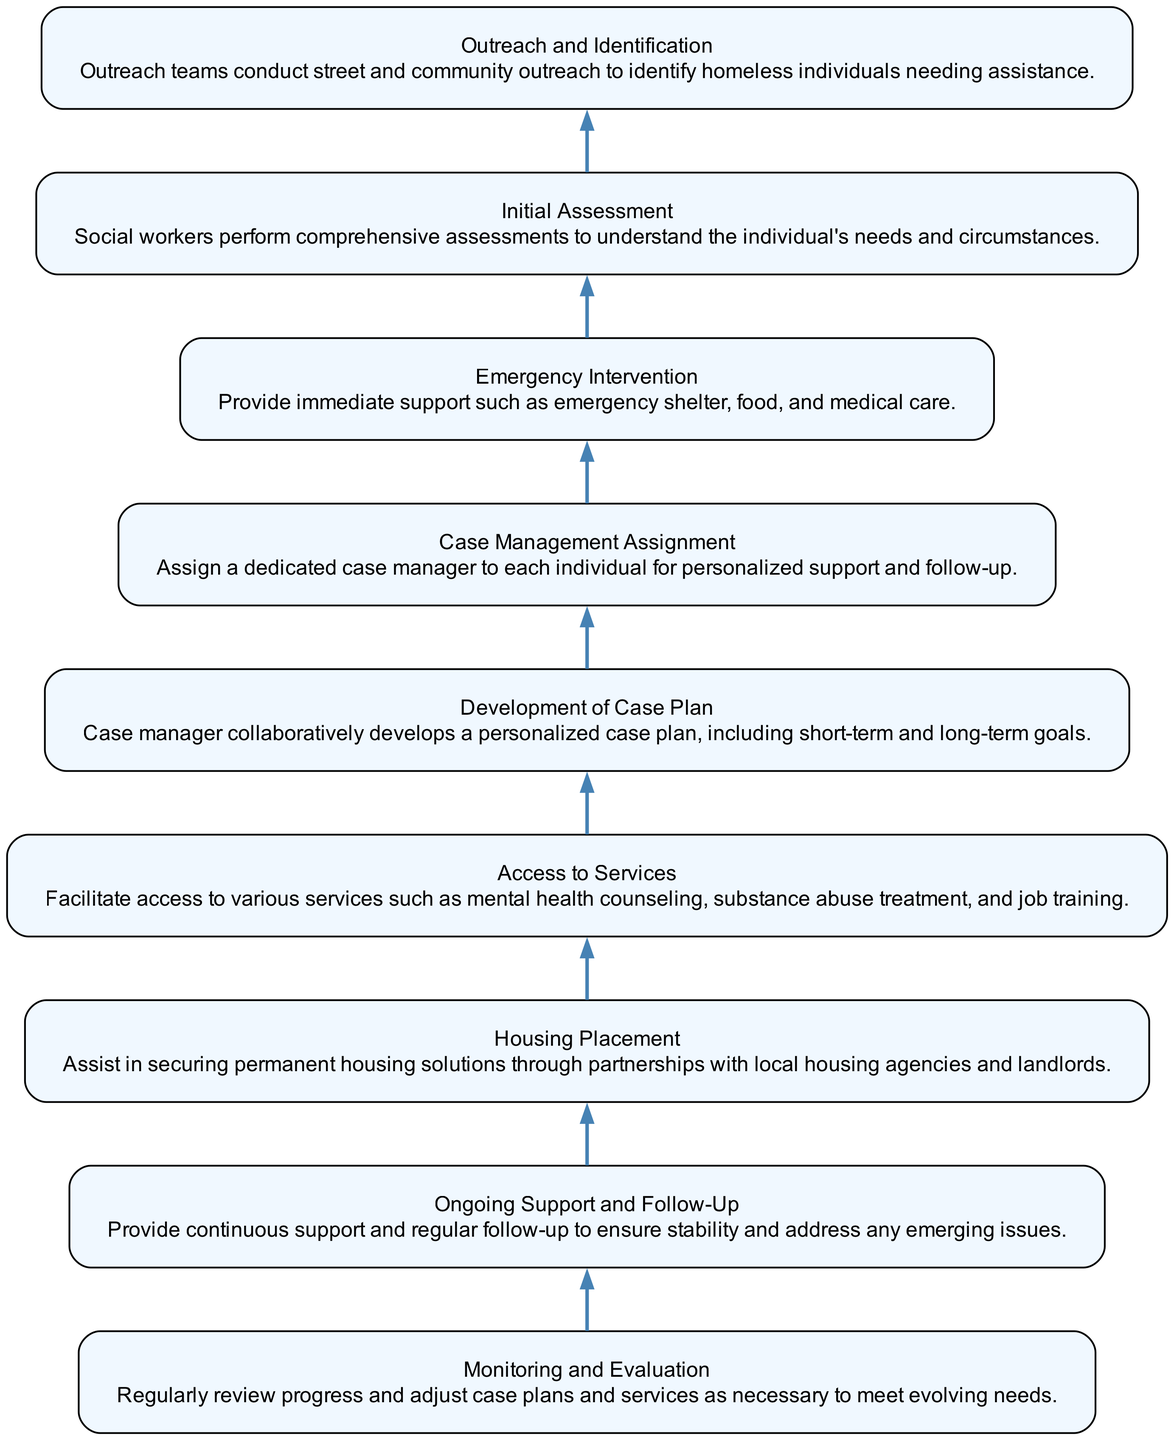What is the first step in the workflow? The first step in the workflow, as indicated by the bottom of the diagram, is "Outreach and Identification." This is the initial stage where outreach teams work to identify homeless individuals who need assistance.
Answer: Outreach and Identification How many steps are there in the workflow? To find the number of steps in the workflow, we can count the nodes in the diagram. There are a total of nine distinct steps, each representing a part of the case management process for homeless individuals.
Answer: 9 What does "Monitoring and Evaluation" lead to? "Monitoring and Evaluation" is at the top of the diagram and does not lead to any further steps; it is the final stage in the workflow. Its purpose is to support ongoing improvement and adjustment of case plans based on evaluations of progress.
Answer: No further steps Which step comes after "Access to Services"? In the flow of the diagram, the step that follows "Access to Services" is "Housing Placement." This indicates that after services are accessed, the next focus is on securing housing solutions.
Answer: Housing Placement What type of support is provided in "Emergency Intervention"? The "Emergency Intervention" step specifies that immediate support includes emergency shelter, food, and medical care. This helps homeless individuals address their most urgent needs.
Answer: Emergency shelter, food, medical care How does "Initial Assessment" relate to "Case Management Assignment"? "Initial Assessment" is the second step in the workflow following "Outreach and Identification." After assessing the individual's needs, the process moves to "Case Management Assignment," where a dedicated case manager is assigned. This indicates a progression from understanding needs to assigning support.
Answer: Case manager assigned What is included in the "Development of Case Plan"? The "Development of Case Plan" involves collaboratively developing a personalized case plan with the individual, which includes both short-term and long-term goals. This reflects a tailored approach based on the assessment.
Answer: Short-term and long-term goals Which step provides ongoing support? The step that explicitly states the provision of ongoing support is "Ongoing Support and Follow-Up." This is crucial for ensuring stability and addressing any emerging issues after initial assistance has been given.
Answer: Ongoing Support and Follow-Up What is the relationship between “Housing Placement” and “Access to Services”? In the workflow, "Access to Services" comes before "Housing Placement," indicating that access to necessary services (such as counseling and job training) prepares individuals for securing housing solutions. This relationship underscores the importance of comprehensive service access before placement.
Answer: Access to services prepares for housing placement What is the role of the case manager in this workflow? The case manager plays a crucial role after being assigned in "Case Management Assignment." Their responsibilities include developing a personalized case plan, facilitating access to services, and providing ongoing support and follow-up to ensure the individual's needs are met.
Answer: Personalized support and coordination of services 